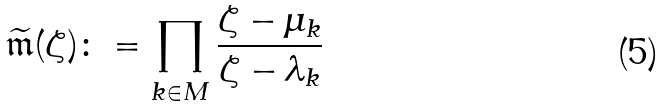<formula> <loc_0><loc_0><loc_500><loc_500>\widetilde { \mathfrak { m } } ( \zeta ) \colon = \prod _ { k \in M } \frac { \zeta - \mu _ { k } } { \zeta - \lambda _ { k } }</formula> 